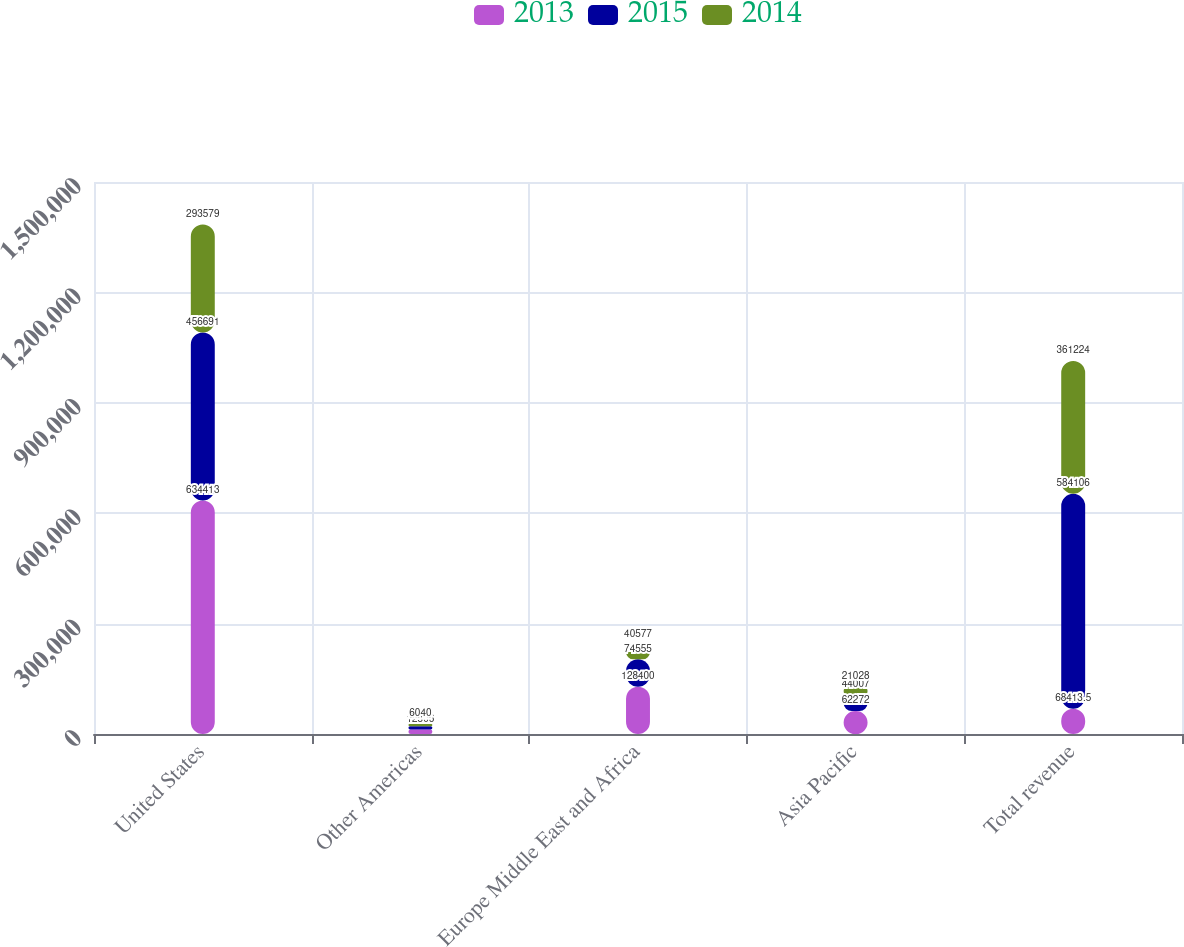Convert chart. <chart><loc_0><loc_0><loc_500><loc_500><stacked_bar_chart><ecel><fcel>United States<fcel>Other Americas<fcel>Europe Middle East and Africa<fcel>Asia Pacific<fcel>Total revenue<nl><fcel>2013<fcel>634413<fcel>12506<fcel>128400<fcel>62272<fcel>68413.5<nl><fcel>2015<fcel>456691<fcel>8853<fcel>74555<fcel>44007<fcel>584106<nl><fcel>2014<fcel>293579<fcel>6040<fcel>40577<fcel>21028<fcel>361224<nl></chart> 